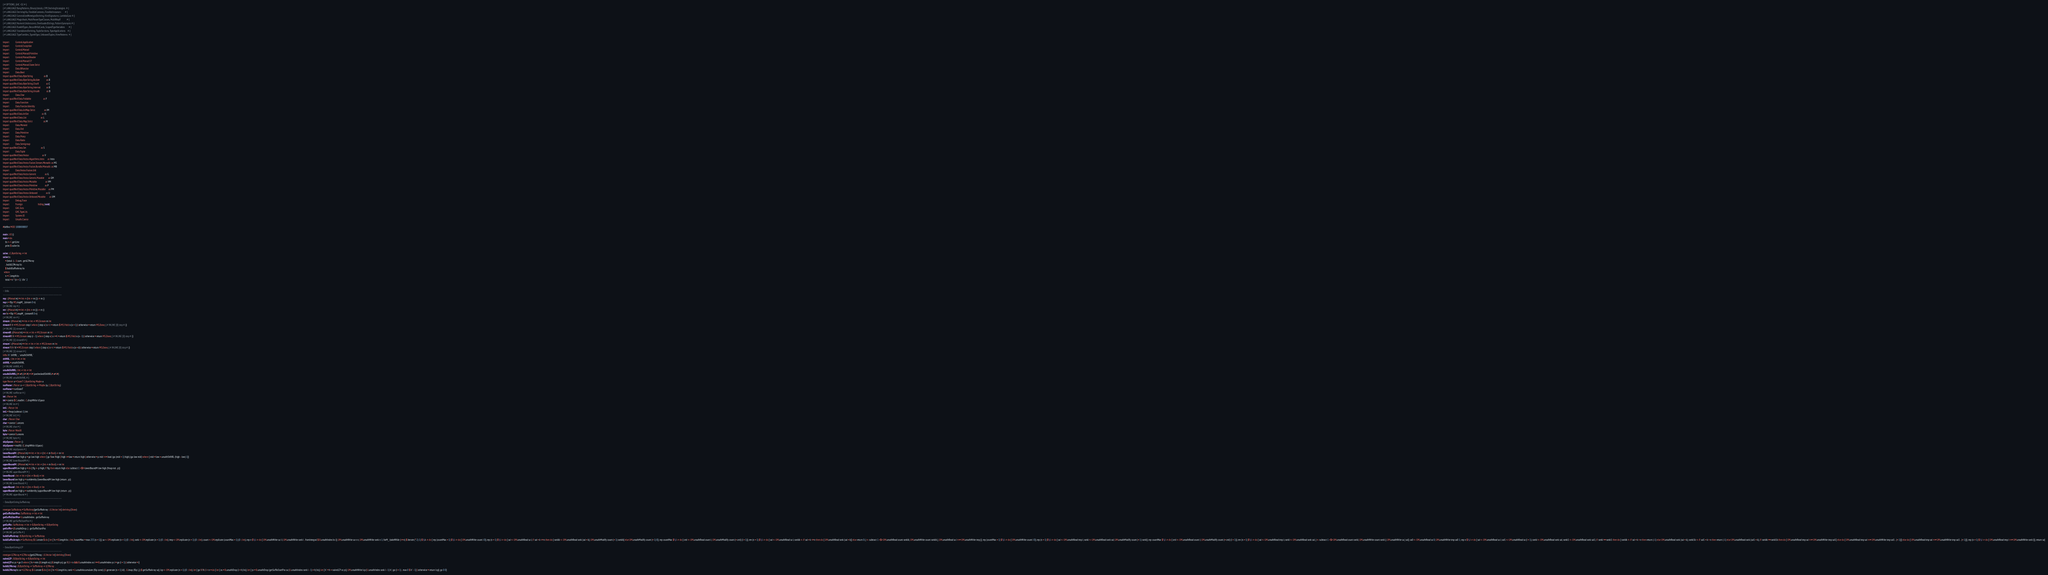Convert code to text. <code><loc_0><loc_0><loc_500><loc_500><_Haskell_>{-# OPTIONS_GHC -O2 #-}
{-# LANGUAGE BangPatterns, BinaryLiterals, CPP, DerivingStrategies  #-}
{-# LANGUAGE DerivingVia, FlexibleContexts, FlexibleInstances       #-}
{-# LANGUAGE GeneralizedNewtypeDeriving, KindSignatures, LambdaCase #-}
{-# LANGUAGE MagicHash, MultiParamTypeClasses, MultiWayIf           #-}
{-# LANGUAGE NumericUnderscores, OverloadedStrings, PatternSynonyms #-}
{-# LANGUAGE RankNTypes, RecordWildCards, ScopedTypeVariables       #-}
{-# LANGUAGE StandaloneDeriving, TupleSections, TypeApplications    #-}
{-# LANGUAGE TypeFamilies, TypeInType, UnboxedTuples, ViewPatterns  #-}

import           Control.Applicative
import           Control.Exception
import           Control.Monad
import           Control.Monad.Primitive
import           Control.Monad.Reader
import           Control.Monad.ST
import           Control.Monad.State.Strict
import           Data.Bifunctor
import           Data.Bool
import qualified Data.ByteString                   as B
import qualified Data.ByteString.Builder           as B
import qualified Data.ByteString.Char8             as C
import qualified Data.ByteString.Internal          as B
import qualified Data.ByteString.Unsafe            as B
import           Data.Char
import qualified Data.Foldable                     as F
import           Data.Function
import           Data.Functor.Identity
import qualified Data.IntMap.Strict                as IM
import qualified Data.IntSet                       as IS
import qualified Data.List                         as L
import qualified Data.Map.Strict                   as M
import           Data.Monoid
import           Data.Ord
import           Data.Primitive
import           Data.Proxy
import           Data.Ratio
import           Data.Semigroup
import qualified Data.Set                          as S
import           Data.Tuple
import qualified Data.Vector                       as V
import qualified Data.Vector.Algorithms.Intro      as Intro
import qualified Data.Vector.Fusion.Stream.Monadic as MS
import qualified Data.Vector.Fusion.Bundle.Monadic as MB
import           Data.Vector.Fusion.Util
import qualified Data.Vector.Generic               as G
import qualified Data.Vector.Generic.Mutable       as GM
import qualified Data.Vector.Mutable               as VM
import qualified Data.Vector.Primitive             as P
import qualified Data.Vector.Primitive.Mutable     as PM
import qualified Data.Vector.Unboxed               as U
import qualified Data.Vector.Unboxed.Mutable       as UM
import           Debug.Trace
import           Foreign                           hiding (void)
import           GHC.Exts
import           GHC.TypeLits
import           System.IO
import           Unsafe.Coerce

#define MOD 1000000007

main :: IO ()
main = do
    bs <- C.getLine
    print $ solve bs

solve :: C.ByteString -> Int
solve bs
    = (total -) . U.sum . getLCPArray
    . buildLCPArray bs
    $ buildSuffixArray bs
  where
    n = C.length bs
    total = n * (n + 1) `div` 2

-------------------------------------------------------------------------------
-- Utils
-------------------------------------------------------------------------------
rep :: (Monad m) => Int -> (Int -> m ()) -> m ()
rep n = flip MS.mapM_ (stream 0 n)
{-# INLINE rep #-}
rev :: (Monad m) => Int -> (Int -> m ()) -> m ()
rev !n = flip MS.mapM_ (streamR 0 n)
{-# INLINE rev #-}
stream :: (Monad m) => Int -> Int -> MS.Stream m Int
stream !l !r = MS.Stream step l where { step x | x < r = return $ MS.Yield x (x + 1) | otherwise = return MS.Done; {-# INLINE [0] step #-}}
{-# INLINE [1] stream #-}
streamR :: (Monad m) => Int -> Int -> MS.Stream m Int
streamR !l !r = MS.Stream step (r - 1) where { step x | x >= l = return $ MS.Yield x (x - 1) | otherwise = return MS.Done; {-# INLINE [0] step #-}}
{-# INLINE [1] streamR #-}
stream' :: (Monad m) => Int -> Int -> Int -> MS.Stream m Int
stream' !l !r !d = MS.Stream step l where { step x | x < r = return $ MS.Yield x (x + d) | otherwise = return MS.Done; {-# INLINE [0] step #-}}
{-# INLINE [1] stream' #-}
infixl 8 `shiftRL`, `unsafeShiftRL`
shiftRL :: Int -> Int -> Int
shiftRL = unsafeShiftRL
{-# INLINE shiftRL #-}
unsafeShiftRL :: Int -> Int -> Int
unsafeShiftRL (I# x#) (I# i#) = I# (uncheckedIShiftRL# x# i#)
{-# INLINE unsafeShiftRL #-}
type Parser a = StateT C.ByteString Maybe a
runParser :: Parser a -> C.ByteString -> Maybe (a, C.ByteString)
runParser = runStateT
{-# INLINE runParser #-}
int :: Parser Int
int = coerce $ C.readInt . C.dropWhile isSpace
{-# INLINE int #-}
int1 :: Parser Int
int1 = fmap (subtract 1) int
{-# INLINE int1 #-}
char :: Parser Char
char = coerce C.uncons
{-# INLINE char #-}
byte :: Parser Word8
byte = coerce B.uncons
{-# INLINE byte #-}
skipSpaces :: Parser ()
skipSpaces = modify' (C.dropWhile isSpace)
{-# INLINE skipSpaces #-}
lowerBoundM :: (Monad m) => Int -> Int -> (Int -> m Bool) -> m Int
lowerBoundM low high p = go low high where { go !low !high | high <= low = return high | otherwise = p mid >>= bool (go (mid + 1) high) (go low mid) where { mid = low + unsafeShiftRL (high - low) 1}}
{-# INLINE lowerBoundM #-}
upperBoundM :: (Monad m) => Int -> Int -> (Int -> m Bool) -> m Int
upperBoundM low high p = do { flg <- p high; if flg then return high else subtract 1 <$!> lowerBoundM low high (fmap not . p)}
{-# INLINE upperBoundM #-}
lowerBound :: Int -> Int -> (Int -> Bool) -> Int
lowerBound low high p = runIdentity (lowerBoundM low high (return . p))
{-# INLINE lowerBound #-}
upperBound :: Int -> Int -> (Int -> Bool) -> Int
upperBound low high p = runIdentity (upperBoundM low high (return . p))
{-# INLINE upperBound #-}
-------------------------------------------------------------------------------
-- Data.ByteString.SuffixArray
-------------------------------------------------------------------------------
newtype SuffixArray = SuffixArray{getSuffixArray :: U.Vector Int} deriving (Show)
getSuffixStartPos :: SuffixArray -> Int -> Int
getSuffixStartPos = U.unsafeIndex . getSuffixArray
{-# INLINE getSuffixStartPos #-}
getSuffix :: SuffixArray -> Int -> B.ByteString -> B.ByteString
getSuffix = (B.unsafeDrop .) . getSuffixStartPos
{-# INLINE getSuffix #-}
buildSuffixArray :: B.ByteString -> SuffixArray
buildSuffixArray bs = SuffixArray $ U.create $ do { let { !n = B.length bs :: Int; !countMax = max 255 (n + 1)}; sa <- UM.replicate (n + 1) (0 :: Int); rank <- UM.replicate (n + 1) (0 :: Int); tmp <- UM.replicate (n + 1) (0 :: Int); count <- UM.replicate (countMax + 1) (0 :: Int); rep n $ \ i -> do { UM.unsafeWrite sa i i; UM.unsafeWrite rank i . fromIntegral $ B.unsafeIndex bs i}; UM.unsafeWrite sa n n; UM.unsafeWrite rank n 1; forM_ (takeWhile (<= n) $ iterate (* 2) 1) $ \ k -> do { rep (countMax + 1) $ \ i -> do { UM.unsafeWrite count i 0}; rep (n + 1) $ \ i -> do { sai <- UM.unsafeRead sa i; if sai + k <= n then do { rankik <- UM.unsafeRead rank (sai + k); UM.unsafeModify count (+ 1) rankik} else UM.unsafeModify count (+ 1) 0}; rep countMax $ \ i -> do { cnti <- UM.unsafeRead count i; UM.unsafeModify count (+ cnti) (i + 1)}; rev (n + 1) $ \ i -> do { sai <- UM.unsafeRead sa i; rankik <- if sai + k <= n then do { UM.unsafeRead rank (sai + k)} else return 0; j <- subtract 1 <$> UM.unsafeRead count rankik; UM.unsafeWrite count rankik j; UM.unsafeRead sa i >>= UM.unsafeWrite tmp j}; rep (countMax + 1) $ \ i -> do { UM.unsafeWrite count i 0}; rep (n + 1) $ \ i -> do { sai <- UM.unsafeRead tmp i; ranki <- UM.unsafeRead rank sai; UM.unsafeModify count (+ 1) ranki}; rep countMax $ \ i -> do { cnti <- UM.unsafeRead count i; UM.unsafeModify count (+ cnti) (i + 1)}; rev (n + 1) $ \ i -> do { sai <- UM.unsafeRead tmp i; ranki <- UM.unsafeRead rank sai; j <- subtract 1 <$> UM.unsafeRead count ranki; UM.unsafeWrite count ranki j; UM.unsafeWrite sa j sai}; sa0 <- UM.unsafeRead sa 0; UM.unsafeWrite tmp sa0 1; rep n $ \ i -> do { sai <- UM.unsafeRead sa i; sai1 <- UM.unsafeRead sa (i + 1); ranki <- UM.unsafeRead rank sai; ranki1 <- UM.unsafeRead rank sai1; if ranki == ranki1 then do { rankik <- if sai + k > n then return (-1) else UM.unsafeRead rank (sai + k); ranki1k <- if sai1 + k > n then return (-1) else UM.unsafeRead rank (sai1 + k); if rankik == ranki1k then do { UM.unsafeRead tmp sai >>= UM.unsafeWrite tmp sai1} else do { UM.unsafeRead tmp sai >>= UM.unsafeWrite tmp sai1 . (+ 1)}} else do { UM.unsafeRead tmp sai >>= UM.unsafeWrite tmp sai1 . (+ 1)}}; rep (n + 1) $ \ i -> do { UM.unsafeRead tmp i >>= UM.unsafeWrite rank i}}; return sa}
-------------------------------------------------------------------------------
-- Data.ByteString.LCP
-------------------------------------------------------------------------------
newtype LCPArray = LCPArray{getLCPArray :: U.Vector Int} deriving (Show)
naiveLCP :: B.ByteString -> B.ByteString -> Int
naiveLCP xs ys = go 0 where { !n = min (B.length xs) (B.length ys); go !i | i < n && B.unsafeIndex xs i == B.unsafeIndex ys i = go (i + 1) | otherwise = i}
buildLCPArray :: B.ByteString -> SuffixArray -> LCPArray
buildLCPArray bs sa = LCPArray $ U.create $ do { let { !n = B.length bs; rank = U.unsafeAccumulate (flip const) (U.generate (n + 1) id) . U.imap (flip (,)) $ getSuffixArray sa}; lcp <- UM.replicate (n + 1) (0 :: Int); let { go !i !h | i < n = do { let { xs = B.unsafeDrop (i + h) bs}; let { ys = B.unsafeDrop (getSuffixStartPos sa (U.unsafeIndex rank i - 1) + h) bs}; let { h' = h + naiveLCP xs ys}; UM.unsafeWrite lcp (U.unsafeIndex rank i - 1) h'; go (i + 1) . max 0 $ h' - 1} | otherwise = return lcp}; go 0 0}
</code> 